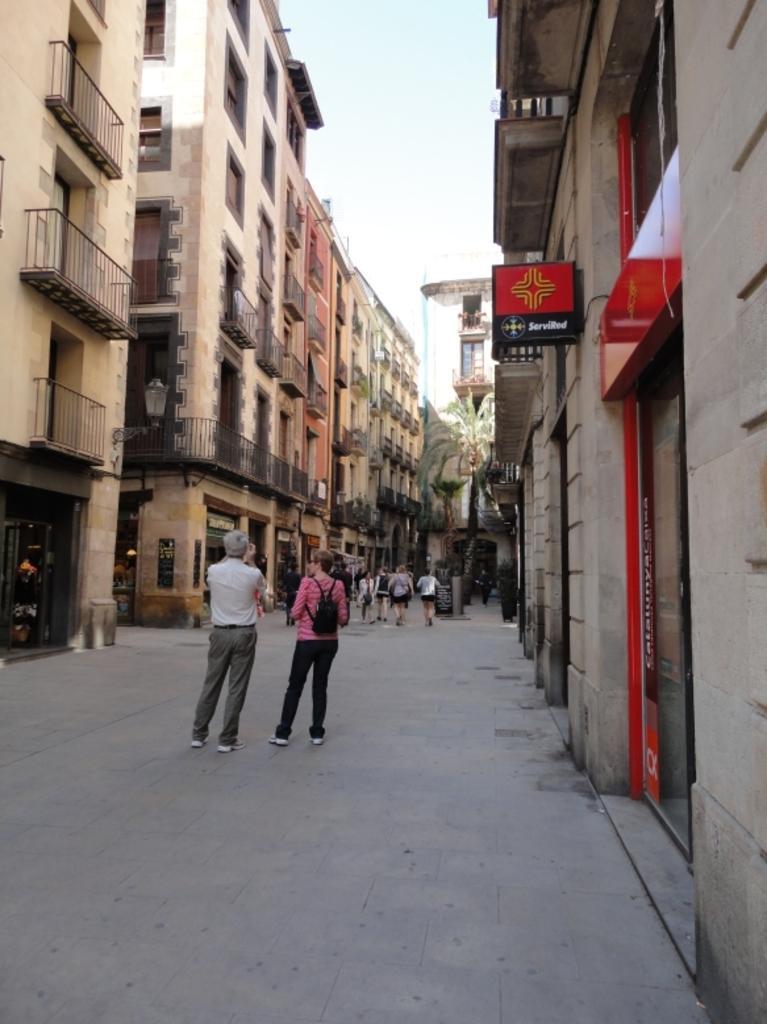Please provide a concise description of this image. In this picture we can see buildings, on the right side there is a board, we can see two persons are standing in the front, there are some people walking in the middle, we can see railings of these buildings, on the left side there is a light, in the background we can see a tree, there is the sky at the top of the picture. 